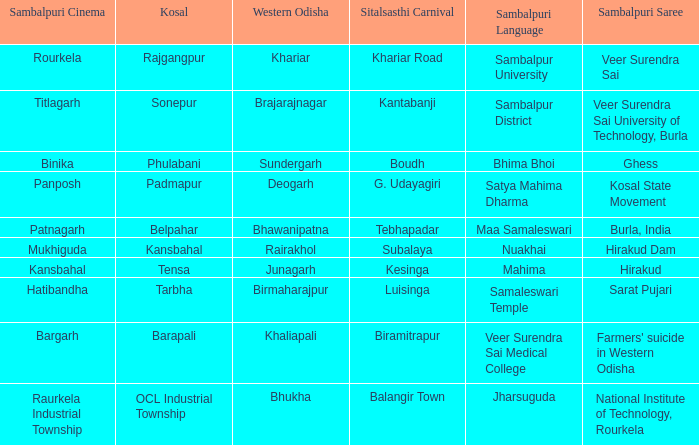How is the hirakud sambalpuri saree connected to the sitalsasthi carnival? Kesinga. 